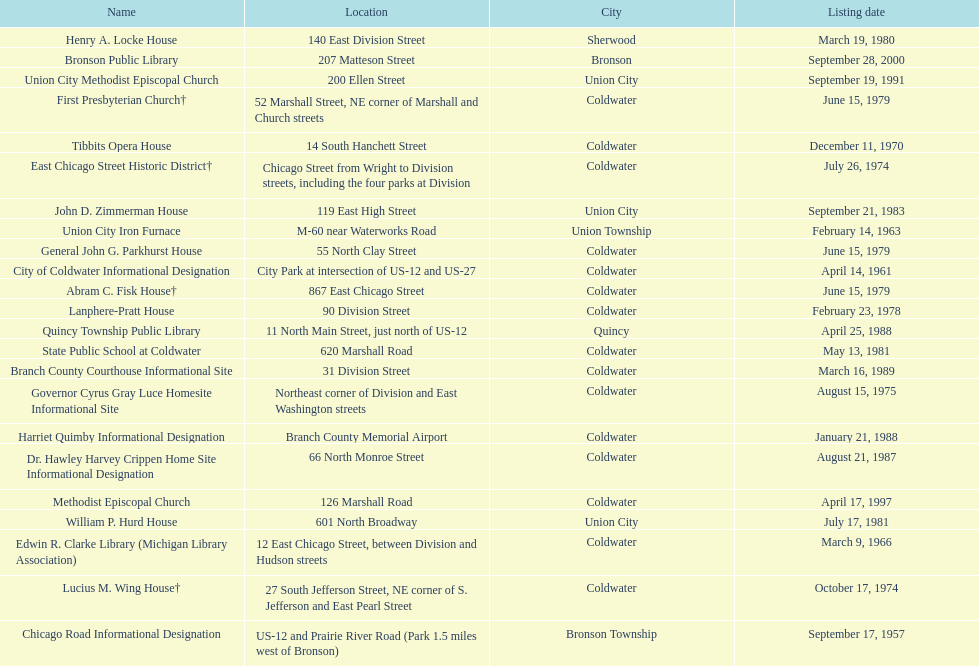Which site was listed earlier, the state public school or the edwin r. clarke library? Edwin R. Clarke Library. 